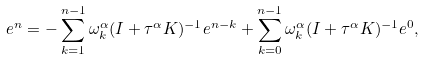<formula> <loc_0><loc_0><loc_500><loc_500>e ^ { n } = - \sum _ { k = 1 } ^ { n - 1 } \omega ^ { \alpha } _ { k } ( I + \tau ^ { \alpha } K ) ^ { - 1 } e ^ { n - k } + \sum _ { k = 0 } ^ { n - 1 } \omega ^ { \alpha } _ { k } ( I + \tau ^ { \alpha } K ) ^ { - 1 } e ^ { 0 } ,</formula> 